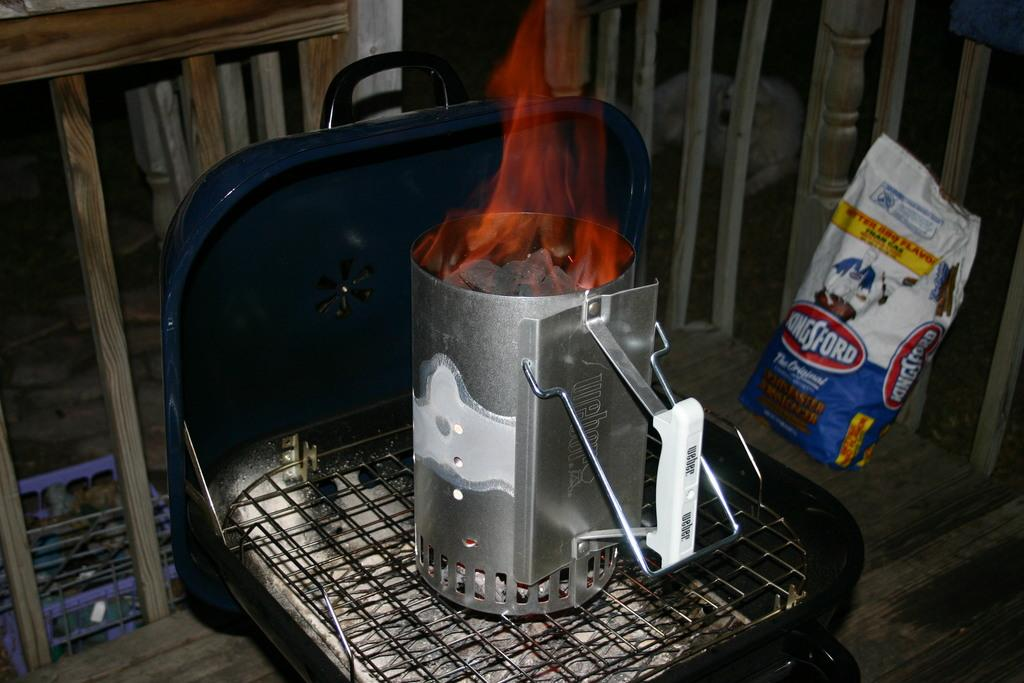Provide a one-sentence caption for the provided image. The coal was lit on fire to begin the BBQ. 